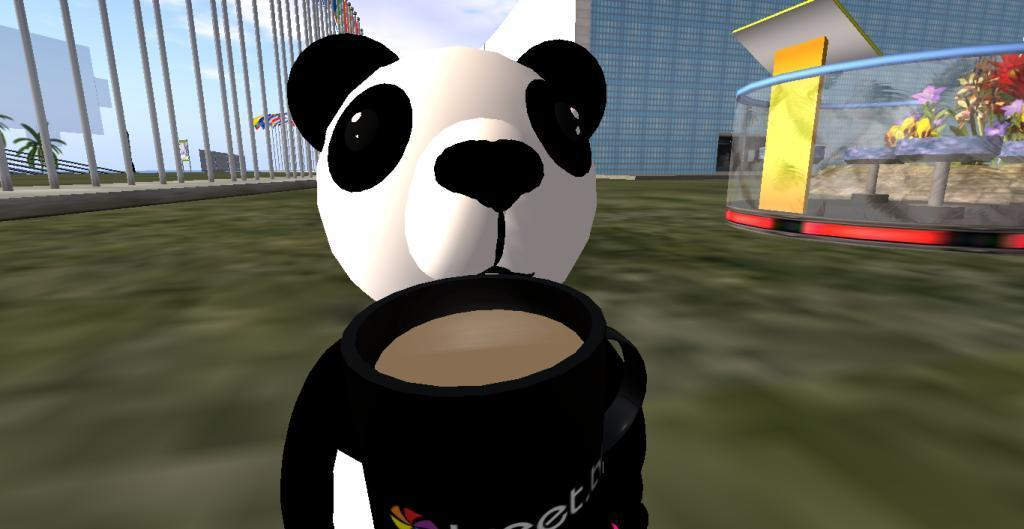What type of structure can be seen in the image? There is a fence in the image. What part of the natural environment is visible in the image? The sky, trees, and flowers are visible in the image. What type of man-made structures can be seen in the image? There are buildings and a statue in the image. How is the whistle being distributed among the trees in the image? There is no whistle present in the image, so it cannot be distributed among the trees. What type of roof is visible on the statue in the image? There is no mention of a roof in the image, and the statue does not have a roof. 